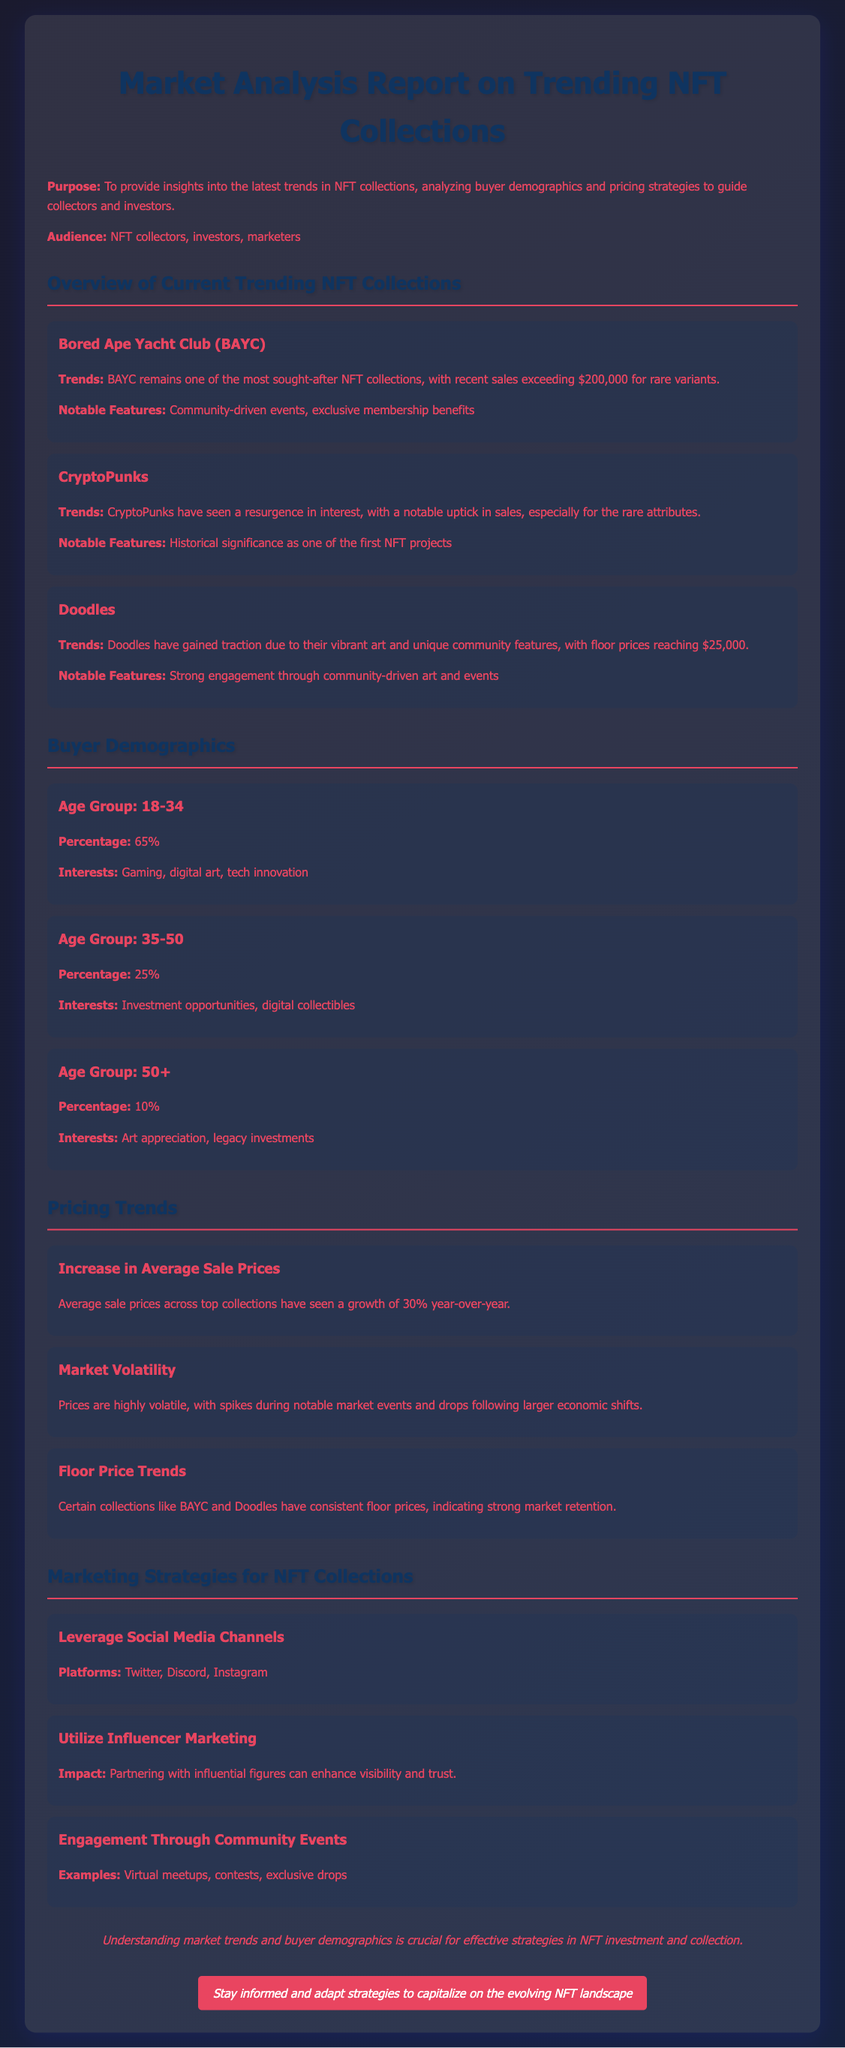What is the primary purpose of the report? The purpose is to provide insights into the latest trends in NFT collections, analyzing buyer demographics and pricing strategies.
Answer: To provide insights into the latest trends in NFT collections Which NFT collection has recent sales exceeding $200,000? BAYC is noted for recent sales exceeding $200,000 for rare variants.
Answer: Bored Ape Yacht Club What percentage of buyers are aged 18-34? The document states that 65% of buyers are aged 18-34.
Answer: 65% Which NFT collection's floor prices have reached at least $25,000? Doodles have gained traction with floor prices reaching $25,000.
Answer: Doodles What year-over-year growth percentage is mentioned for average sale prices? The document indicates an average sale price growth of 30% year-over-year.
Answer: 30% Which two social media platforms are recommended for leveraging marketing strategies? The report highlights Twitter and Instagram as key platforms for marketing.
Answer: Twitter and Instagram What percentage of the buyer demographic is over the age of 50? The age group of 50+ comprises 10% of the buyer demographic.
Answer: 10% What type of engagement is highlighted in the marketing strategies section? Engagement through community events like virtual meetups is emphasized.
Answer: Community events How many age groups are analyzed in the buyer demographics section? Three distinct age groups are analyzed in the document.
Answer: Three 